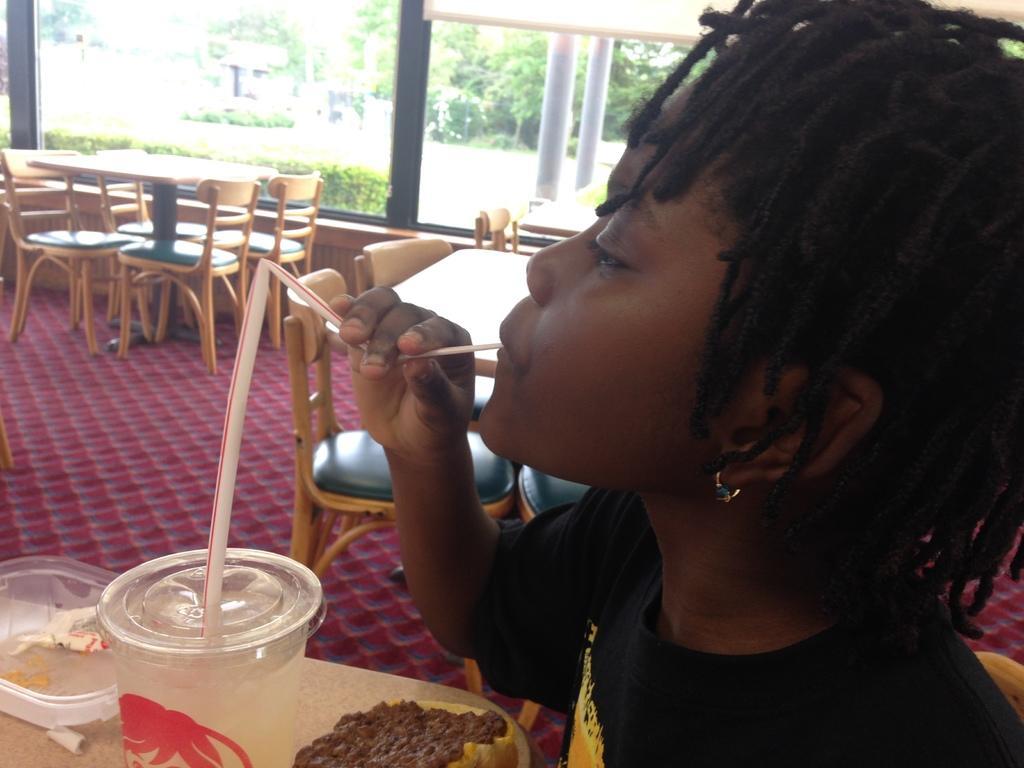How would you summarize this image in a sentence or two? This kid is highlighted in this picture. This kid is drinking with help of this straw. On this table there is a food and this glass. We can able to see number of chairs and tables. These are plants and trees. Floor with carpet. 